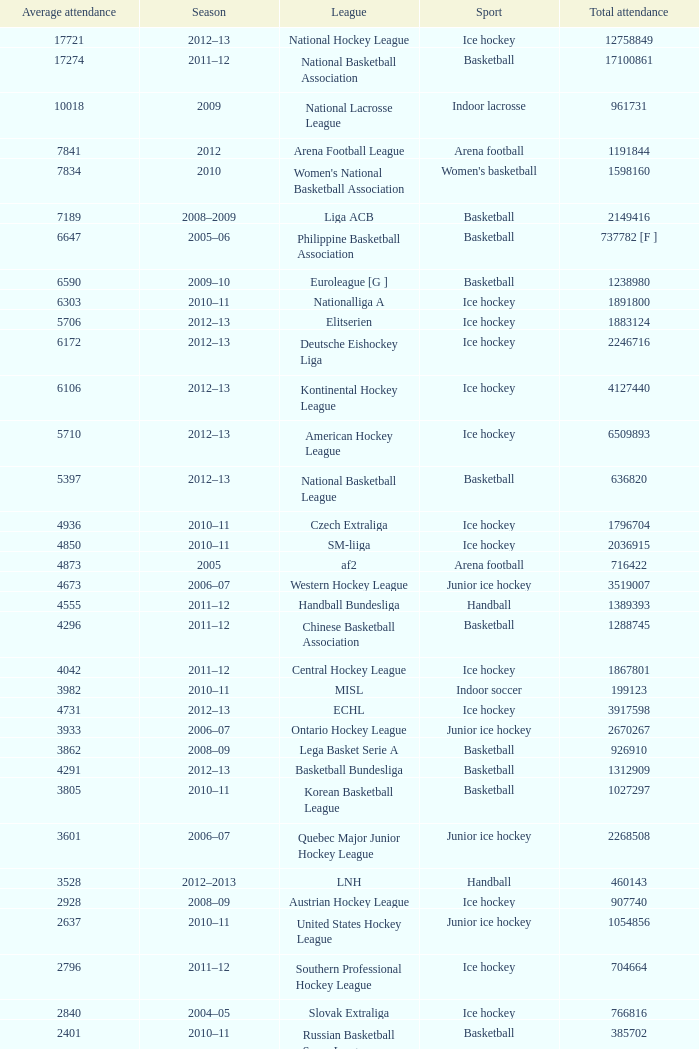What's the total attendance in rink hockey when the average attendance was smaller than 4850? 115000.0. 